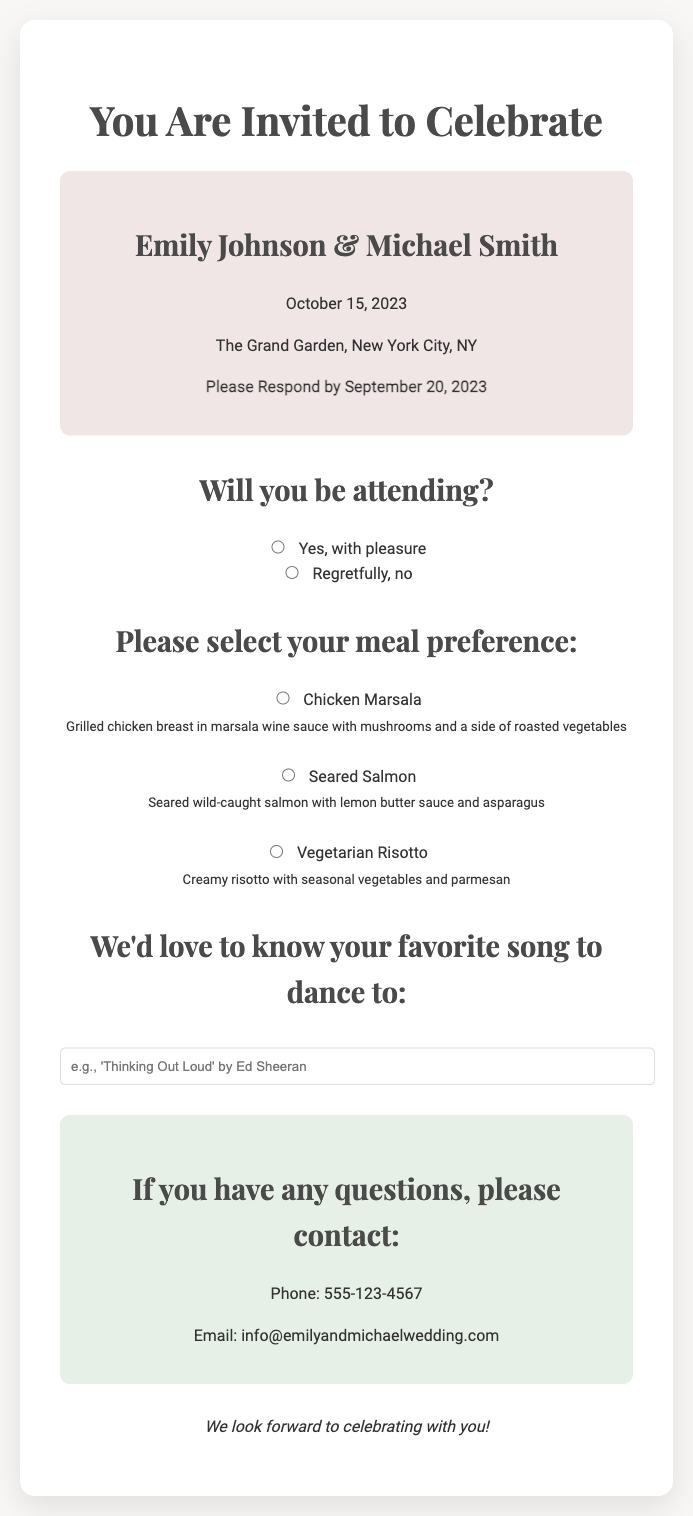What is the name of the couple getting married? The document specifies the names of the couple, which are Emily Johnson and Michael Smith.
Answer: Emily Johnson & Michael Smith When is the wedding date? The document provides the date of the wedding as mentioned in the event details section.
Answer: October 15, 2023 Where will the wedding take place? The location of the wedding is stated in the document, specifically mentioning "The Grand Garden, New York City, NY."
Answer: The Grand Garden, New York City, NY What should guests do by September 20, 2023? The RSVP card instructs guests to respond by a specific date which is clearly mentioned.
Answer: Please Respond What meal options are available? The document lists three meal choices available for the guests: Chicken Marsala, Seared Salmon, and Vegetarian Risotto.
Answer: Chicken Marsala, Seared Salmon, Vegetarian Risotto What kind of request can guests make regarding songs? The RSVP card invites guests to share a favorite song to dance to, which is a specific type of request noted in the document.
Answer: Favorite song to dance to What type of question is this document? The document is an invitation for guests to RSVP to a wedding event, which fits the category of event planning materials.
Answer: RSVP card How can guests contact for any questions? The document provides specific contact information, including a phone number and an email for inquiries.
Answer: Phone: 555-123-4567; Email: info@emilyandmichaelwedding.com What is the main theme of the RSVP card? The overall purpose of the document is to invite guests to celebrate a wedding, which is evident through the celebratory language and layout.
Answer: Wedding invitation 